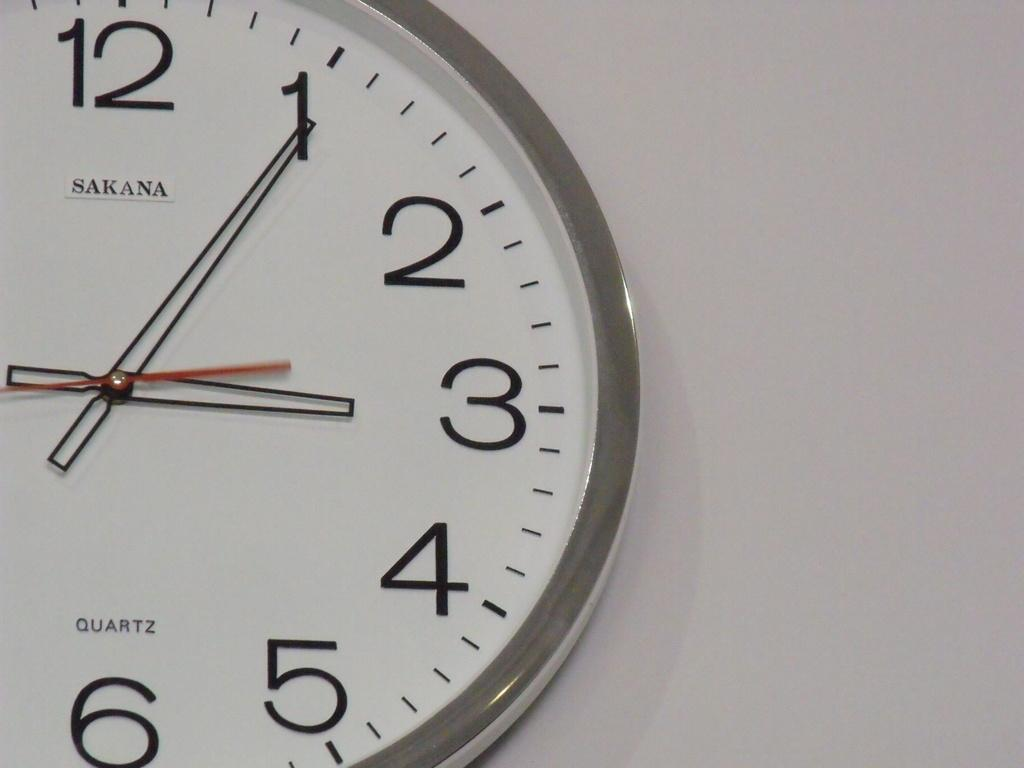<image>
Create a compact narrative representing the image presented. A quartz Sakana clock showing that it is six after three. 